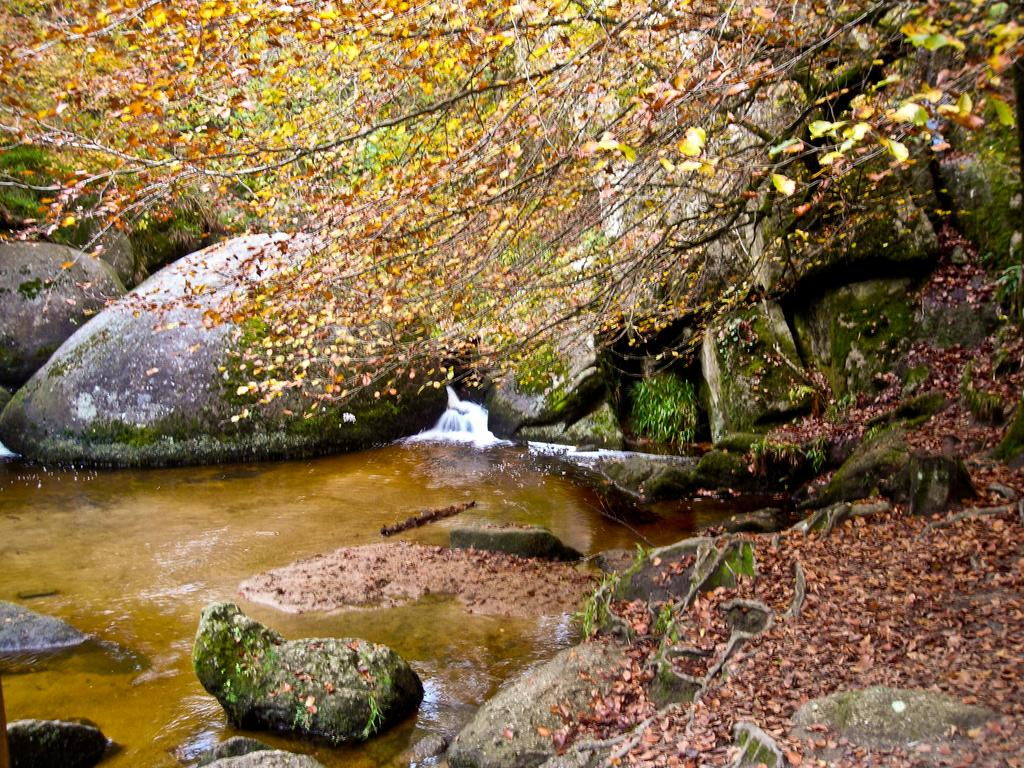What is the primary element visible in the image? There is water in the image. What can be seen near the water? There are big rocks near the water. What is covering the rocks? Leaves are present on the rocks. What is visible above the rocks? There is a tree visible above the rocks. How many beds are visible in the image? There are no beds present in the image. Are there any rabbits hopping around near the water? There are no rabbits visible in the image. 